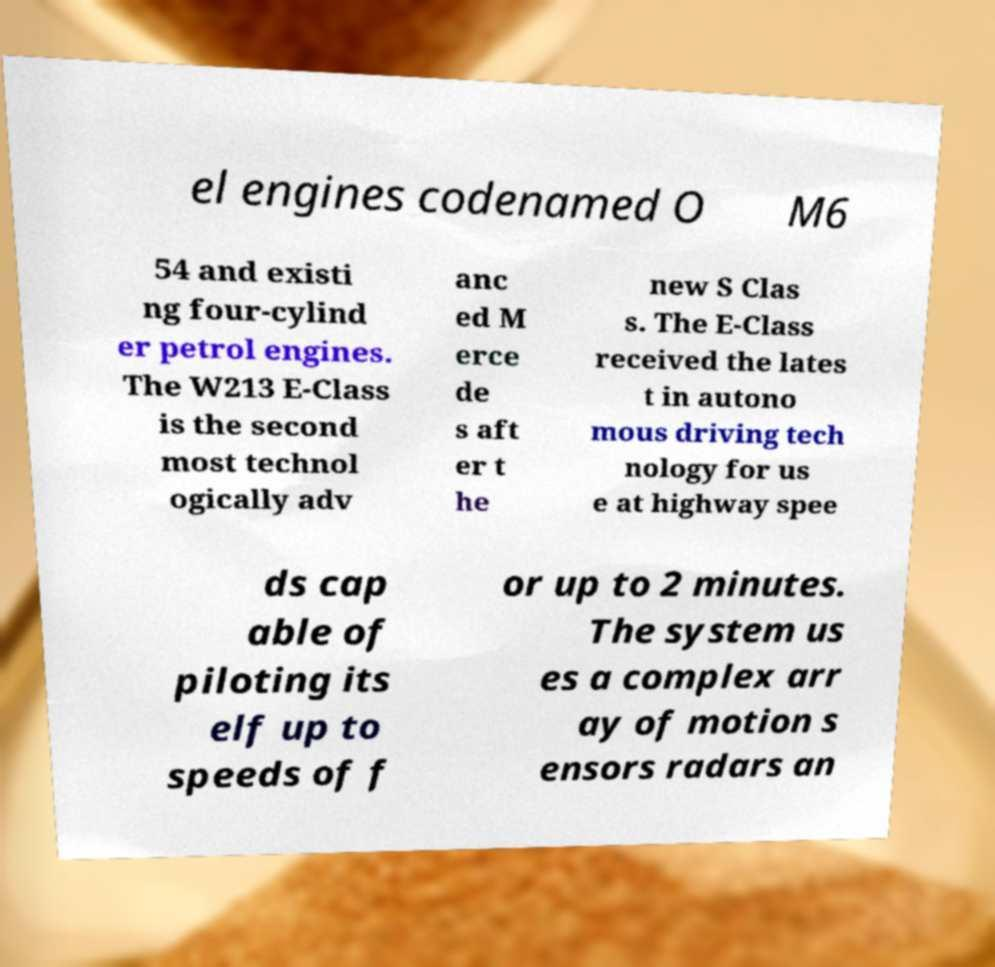What messages or text are displayed in this image? I need them in a readable, typed format. el engines codenamed O M6 54 and existi ng four-cylind er petrol engines. The W213 E-Class is the second most technol ogically adv anc ed M erce de s aft er t he new S Clas s. The E-Class received the lates t in autono mous driving tech nology for us e at highway spee ds cap able of piloting its elf up to speeds of f or up to 2 minutes. The system us es a complex arr ay of motion s ensors radars an 